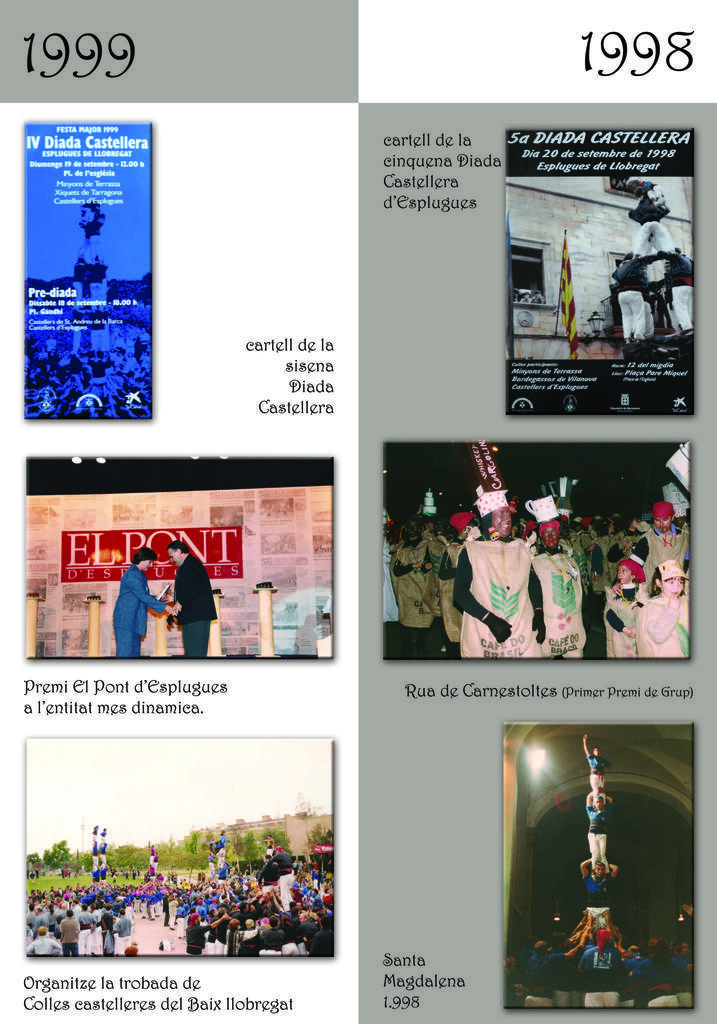What can be seen on the posters in the image? There are different types of posters in the image, and they have images of persons. What else is present on the posters besides the images? The posters contain text. What type of grape can be seen hanging from the stocking in the image? There is no stocking or grape present in the image; the posters contain images of persons and text. 